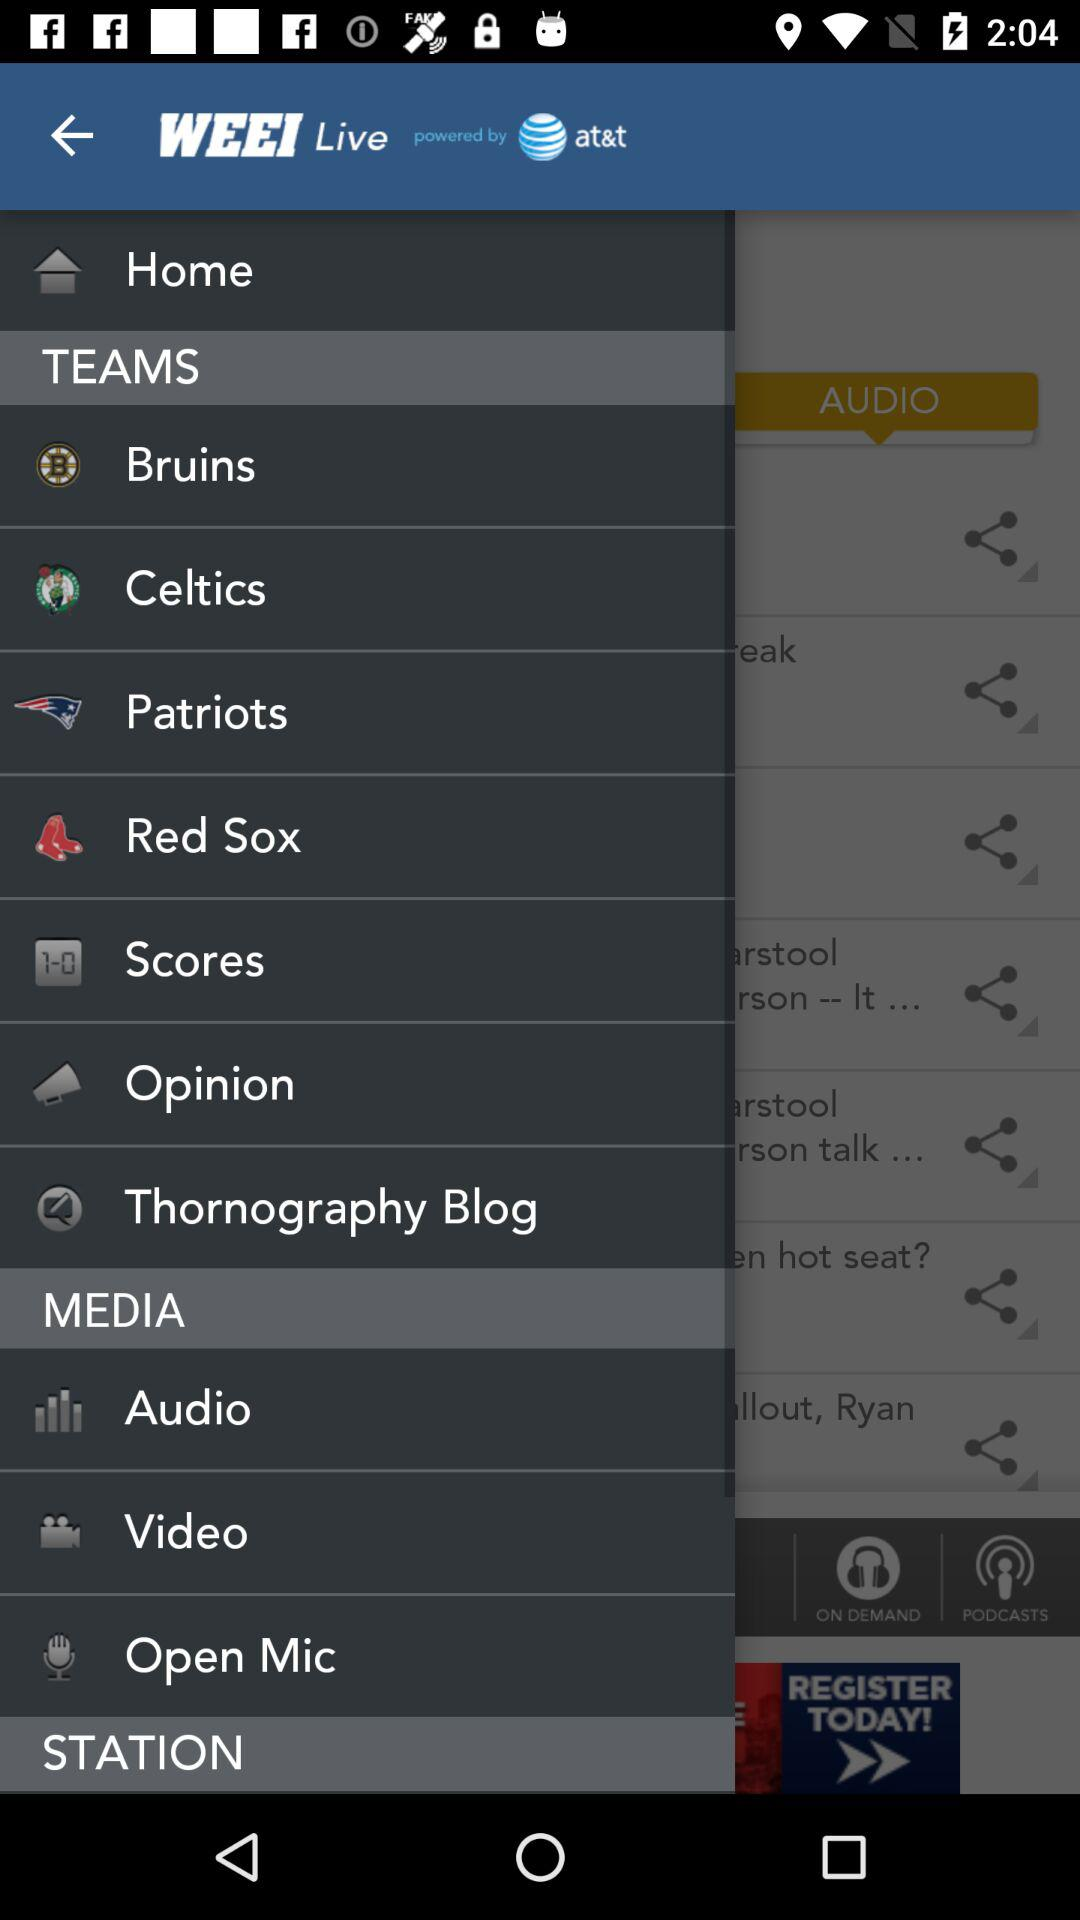What is the name of the application? The name of the application is WEEI live. 